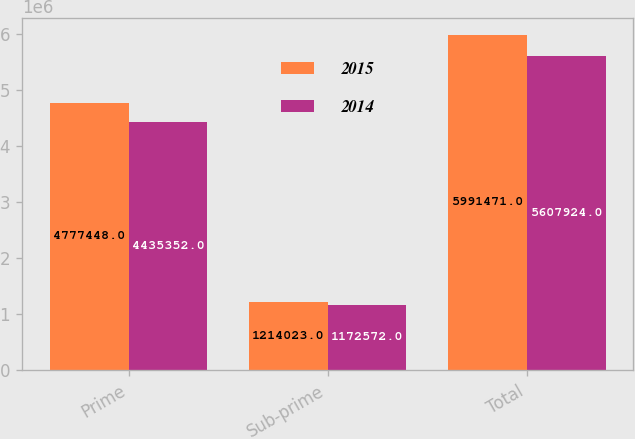Convert chart to OTSL. <chart><loc_0><loc_0><loc_500><loc_500><stacked_bar_chart><ecel><fcel>Prime<fcel>Sub-prime<fcel>Total<nl><fcel>2015<fcel>4.77745e+06<fcel>1.21402e+06<fcel>5.99147e+06<nl><fcel>2014<fcel>4.43535e+06<fcel>1.17257e+06<fcel>5.60792e+06<nl></chart> 